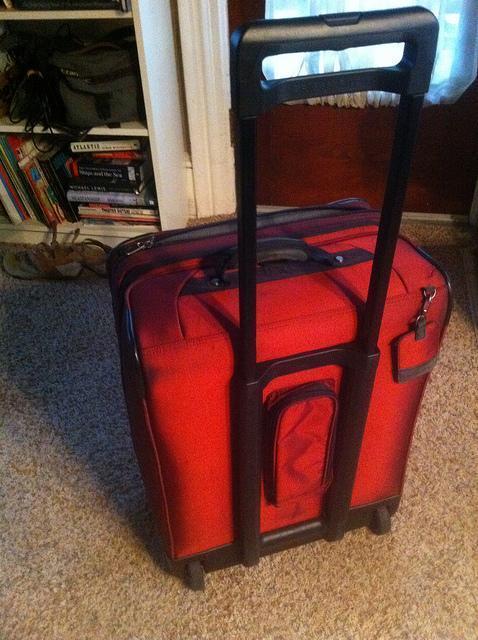How many suitcases are there?
Give a very brief answer. 1. 